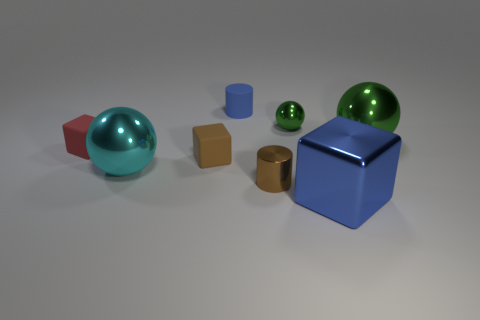What size is the ball in front of the big sphere to the right of the large cube?
Your response must be concise. Large. Is there a blue rubber object of the same size as the red rubber object?
Your answer should be compact. Yes. Does the matte object that is behind the small ball have the same size as the sphere in front of the large green metallic object?
Your answer should be compact. No. What shape is the small green thing that is right of the cylinder that is to the right of the rubber cylinder?
Your answer should be compact. Sphere. How many tiny matte blocks are on the right side of the large green metallic ball?
Make the answer very short. 0. What color is the block that is made of the same material as the red thing?
Make the answer very short. Brown. There is a blue matte cylinder; does it have the same size as the rubber thing that is in front of the tiny red rubber cube?
Provide a succinct answer. Yes. What size is the blue thing that is in front of the tiny rubber thing that is to the left of the big sphere that is in front of the red thing?
Keep it short and to the point. Large. What number of shiny things are either tiny cubes or red blocks?
Make the answer very short. 0. There is a sphere that is behind the large green metallic ball; what color is it?
Provide a short and direct response. Green. 